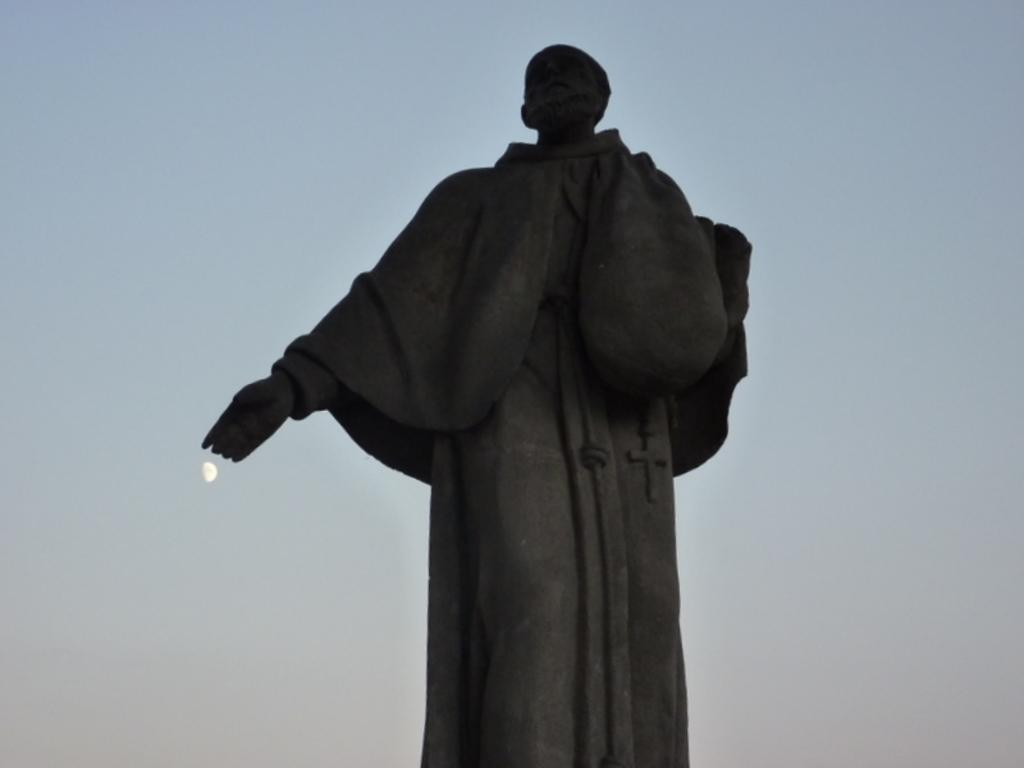What is the main subject in the picture? There is a statue in the picture. What can be seen in the sky in the image? The moon is visible in the sky, and clouds are present. What type of ball is being used by the statue in the image? There is no ball present in the image; the statue is the main subject. 